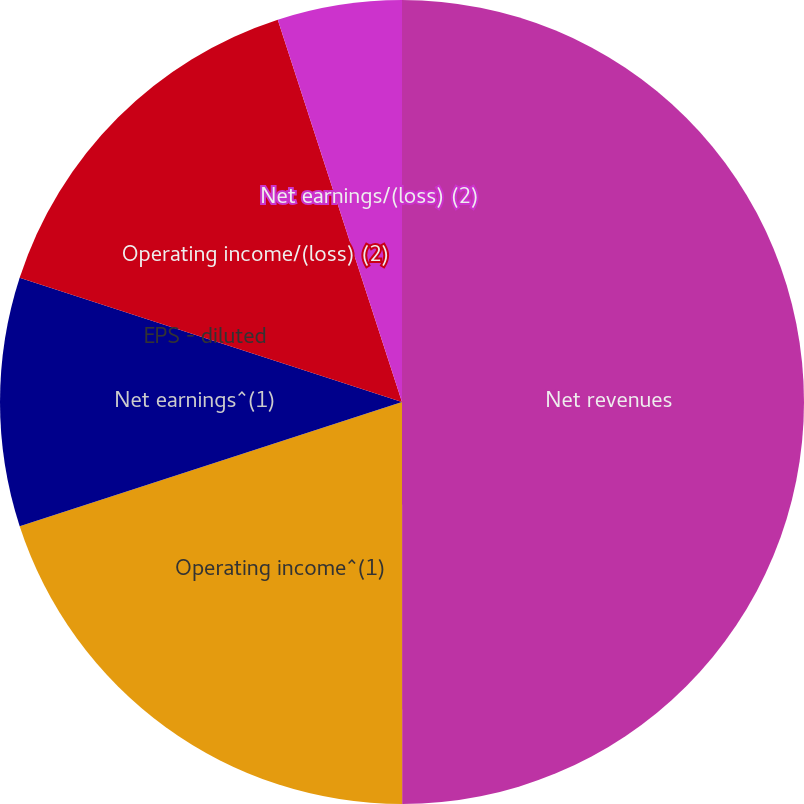<chart> <loc_0><loc_0><loc_500><loc_500><pie_chart><fcel>Net revenues<fcel>Operating income^(1)<fcel>Net earnings^(1)<fcel>EPS - diluted<fcel>Operating income/(loss) (2)<fcel>Net earnings/(loss) (2)<nl><fcel>49.99%<fcel>20.0%<fcel>10.0%<fcel>0.0%<fcel>15.0%<fcel>5.0%<nl></chart> 